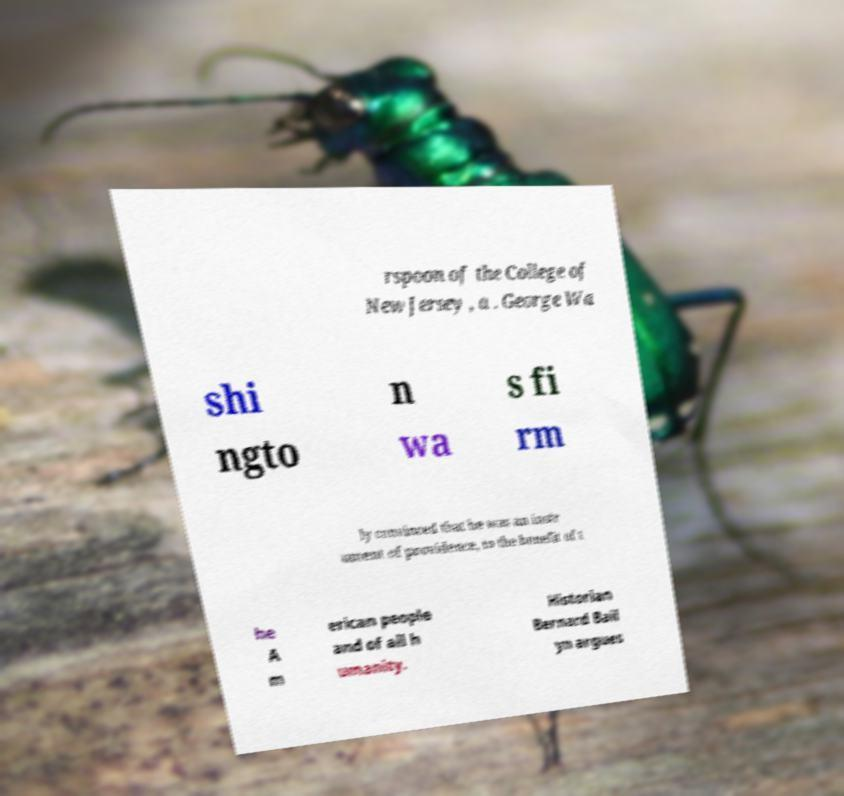For documentation purposes, I need the text within this image transcribed. Could you provide that? rspoon of the College of New Jersey , a . George Wa shi ngto n wa s fi rm ly convinced that he was an instr ument of providence, to the benefit of t he A m erican people and of all h umanity. Historian Bernard Bail yn argues 